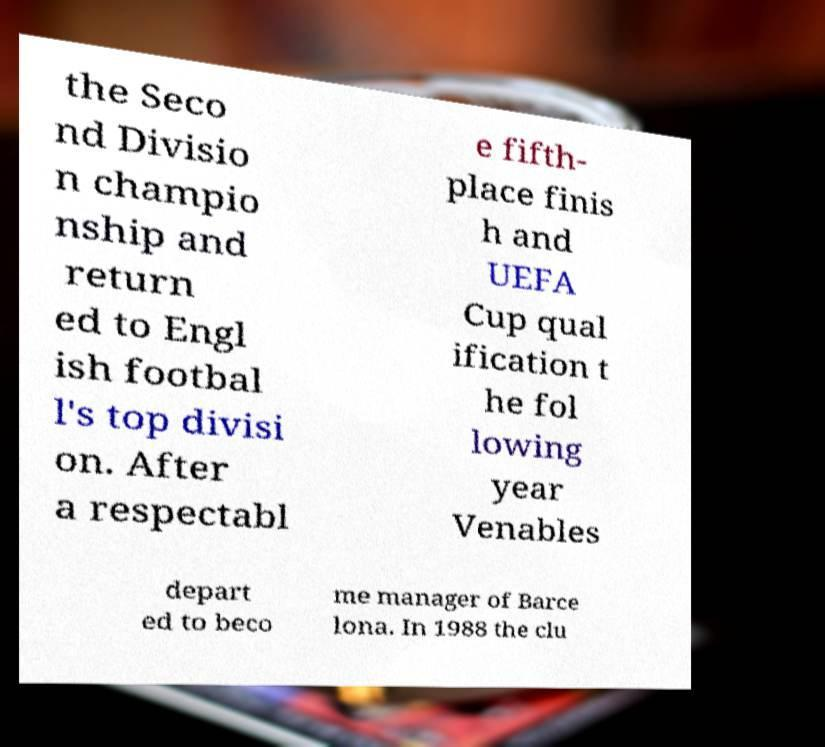What messages or text are displayed in this image? I need them in a readable, typed format. the Seco nd Divisio n champio nship and return ed to Engl ish footbal l's top divisi on. After a respectabl e fifth- place finis h and UEFA Cup qual ification t he fol lowing year Venables depart ed to beco me manager of Barce lona. In 1988 the clu 